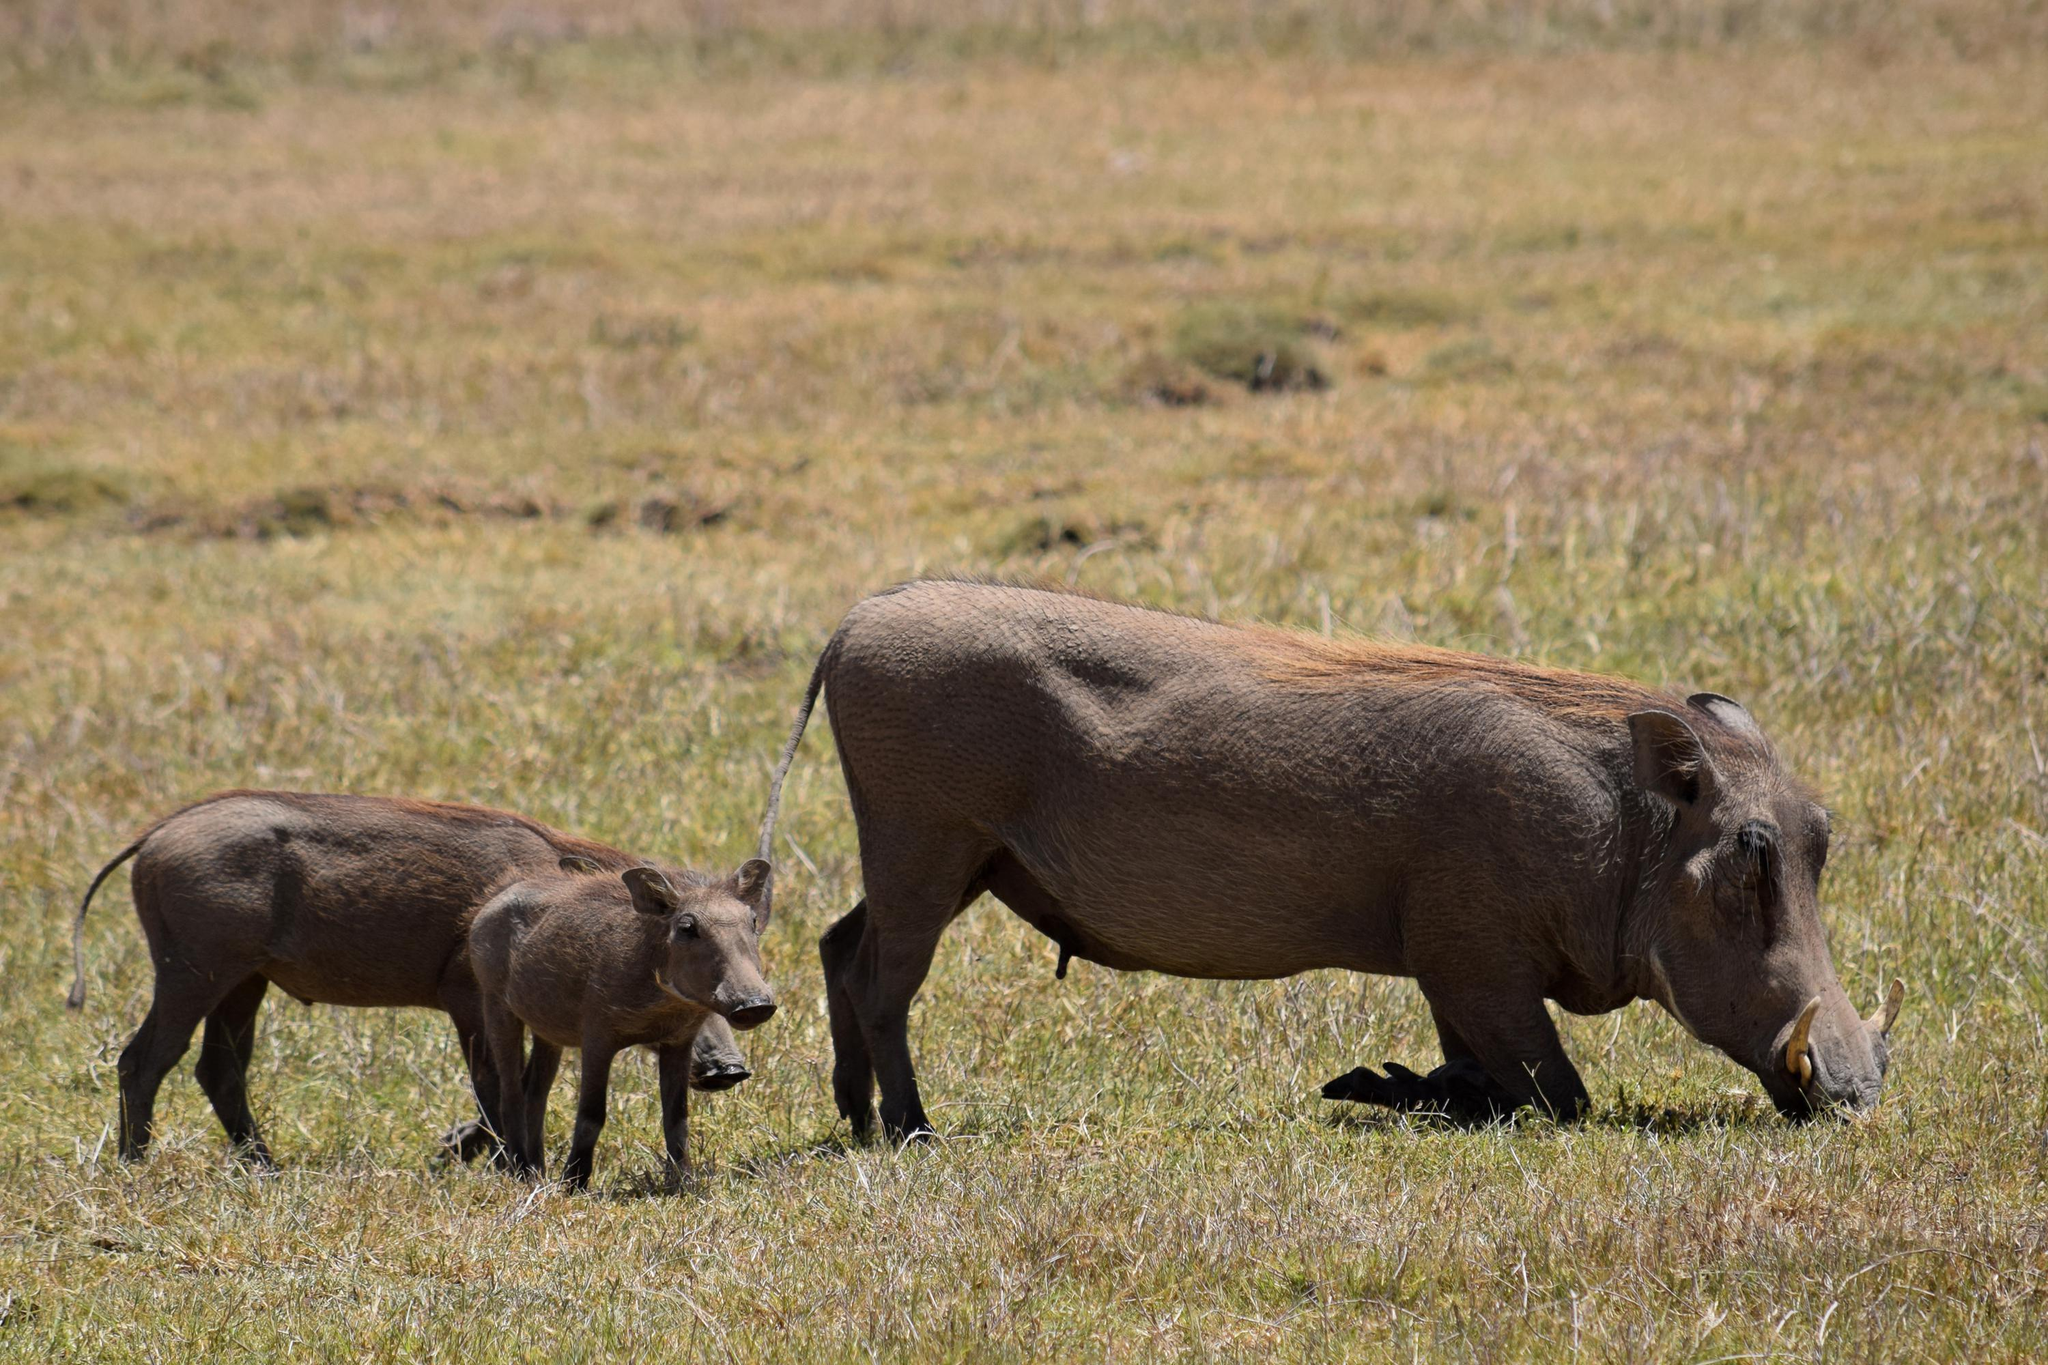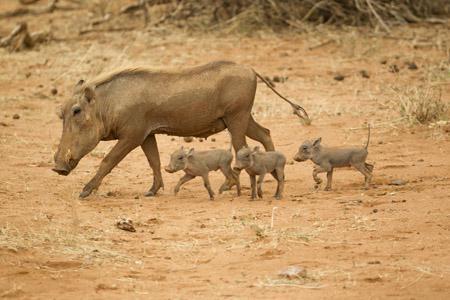The first image is the image on the left, the second image is the image on the right. For the images shown, is this caption "There's exactly two warthogs in the left image." true? Answer yes or no. Yes. 